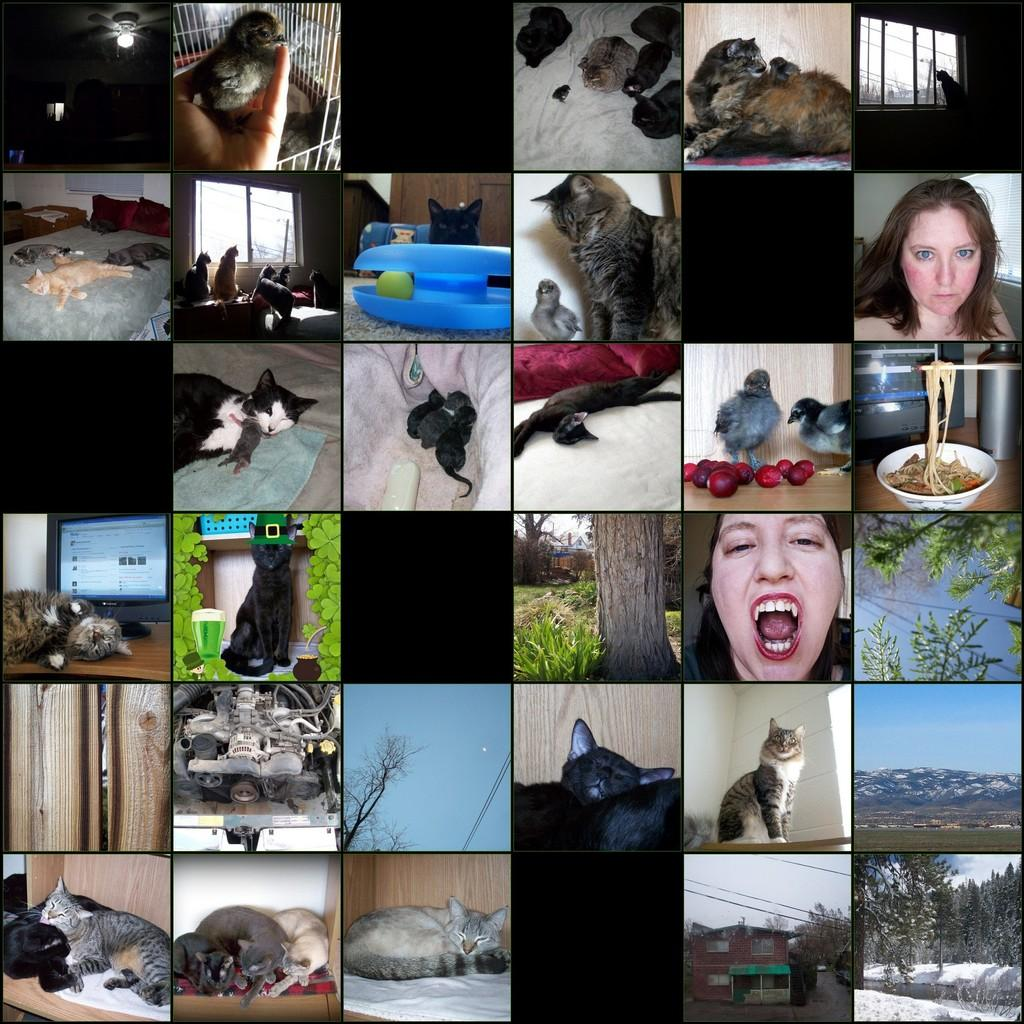What type of lighting is present in the image? There are lights in the image. What animals can be seen in the image? There are birds in the image. What structure is present in the image? There is a cage in the image. What architectural feature is visible in the image? There are windows in the image. What type of animals are present in the image? There are cats in the image. Who is present in the image? There are people in the image. What type of vegetation is visible in the image? There are plants and trees in the image. What part of the natural environment is visible in the image? The sky is visible in the image. What is the weather like in the image? There is snow in the image, suggesting a cold environment. What type of objects are made of wood in the image? There are wooden objects in the image. What type of electronic devices are present in the image? There are monitors in the image. What type of food can be seen in the image? There is food in the image. What type of furniture is present in the image? There is a bed in the image. Where is the cave located in the image? There is no cave present in the image. What type of game is being played in the image? There is no game being played in the image. What is the person using to brush their teeth in the image? There is no toothbrush or brushing activity present in the image. 